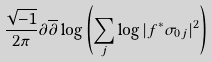<formula> <loc_0><loc_0><loc_500><loc_500>\frac { \sqrt { - 1 } } { 2 \pi } \partial \overline { \partial } \log \left ( \sum _ { j } \log | f ^ { * } \sigma _ { 0 j } | ^ { 2 } \right )</formula> 